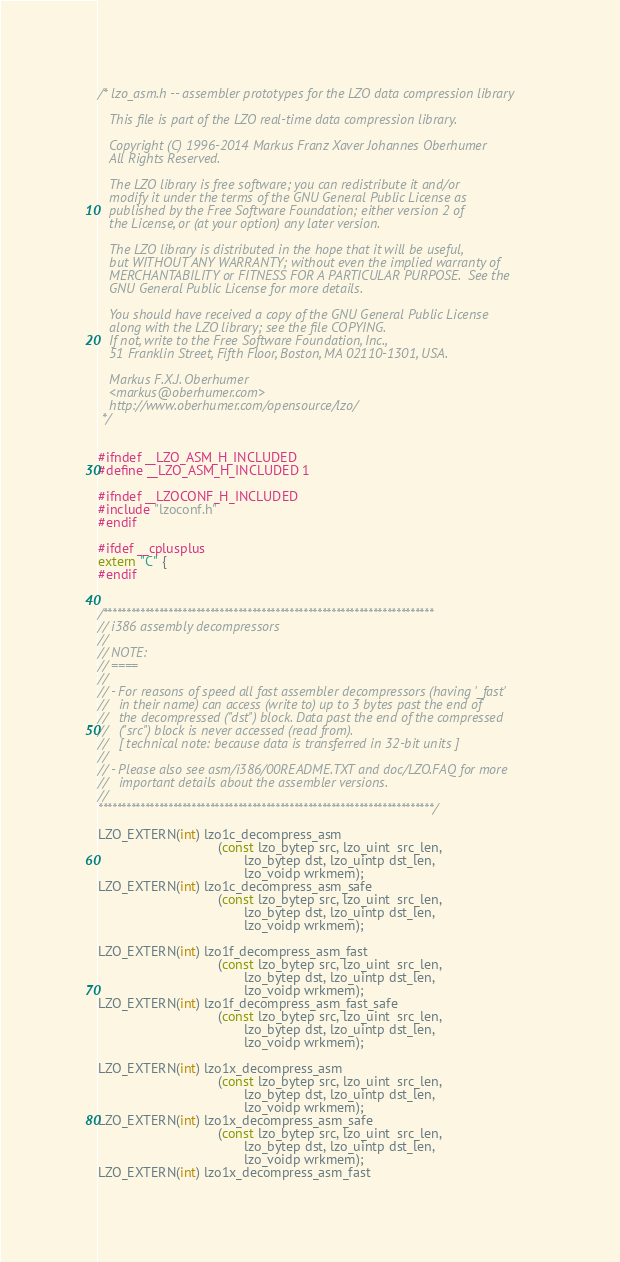Convert code to text. <code><loc_0><loc_0><loc_500><loc_500><_C_>/* lzo_asm.h -- assembler prototypes for the LZO data compression library

   This file is part of the LZO real-time data compression library.

   Copyright (C) 1996-2014 Markus Franz Xaver Johannes Oberhumer
   All Rights Reserved.

   The LZO library is free software; you can redistribute it and/or
   modify it under the terms of the GNU General Public License as
   published by the Free Software Foundation; either version 2 of
   the License, or (at your option) any later version.

   The LZO library is distributed in the hope that it will be useful,
   but WITHOUT ANY WARRANTY; without even the implied warranty of
   MERCHANTABILITY or FITNESS FOR A PARTICULAR PURPOSE.  See the
   GNU General Public License for more details.

   You should have received a copy of the GNU General Public License
   along with the LZO library; see the file COPYING.
   If not, write to the Free Software Foundation, Inc.,
   51 Franklin Street, Fifth Floor, Boston, MA 02110-1301, USA.

   Markus F.X.J. Oberhumer
   <markus@oberhumer.com>
   http://www.oberhumer.com/opensource/lzo/
 */


#ifndef __LZO_ASM_H_INCLUDED
#define __LZO_ASM_H_INCLUDED 1

#ifndef __LZOCONF_H_INCLUDED
#include "lzoconf.h"
#endif

#ifdef __cplusplus
extern "C" {
#endif


/***********************************************************************
// i386 assembly decompressors
//
// NOTE:
// ====
//
// - For reasons of speed all fast assembler decompressors (having '_fast'
//   in their name) can access (write to) up to 3 bytes past the end of
//   the decompressed ("dst") block. Data past the end of the compressed
//   ("src") block is never accessed (read from).
//   [ technical note: because data is transferred in 32-bit units ]
//
// - Please also see asm/i386/00README.TXT and doc/LZO.FAQ for more
//   important details about the assembler versions.
//
************************************************************************/

LZO_EXTERN(int) lzo1c_decompress_asm
                                (const lzo_bytep src, lzo_uint  src_len,
                                       lzo_bytep dst, lzo_uintp dst_len,
                                       lzo_voidp wrkmem);
LZO_EXTERN(int) lzo1c_decompress_asm_safe
                                (const lzo_bytep src, lzo_uint  src_len,
                                       lzo_bytep dst, lzo_uintp dst_len,
                                       lzo_voidp wrkmem);

LZO_EXTERN(int) lzo1f_decompress_asm_fast
                                (const lzo_bytep src, lzo_uint  src_len,
                                       lzo_bytep dst, lzo_uintp dst_len,
                                       lzo_voidp wrkmem);
LZO_EXTERN(int) lzo1f_decompress_asm_fast_safe
                                (const lzo_bytep src, lzo_uint  src_len,
                                       lzo_bytep dst, lzo_uintp dst_len,
                                       lzo_voidp wrkmem);

LZO_EXTERN(int) lzo1x_decompress_asm
                                (const lzo_bytep src, lzo_uint  src_len,
                                       lzo_bytep dst, lzo_uintp dst_len,
                                       lzo_voidp wrkmem);
LZO_EXTERN(int) lzo1x_decompress_asm_safe
                                (const lzo_bytep src, lzo_uint  src_len,
                                       lzo_bytep dst, lzo_uintp dst_len,
                                       lzo_voidp wrkmem);
LZO_EXTERN(int) lzo1x_decompress_asm_fast</code> 